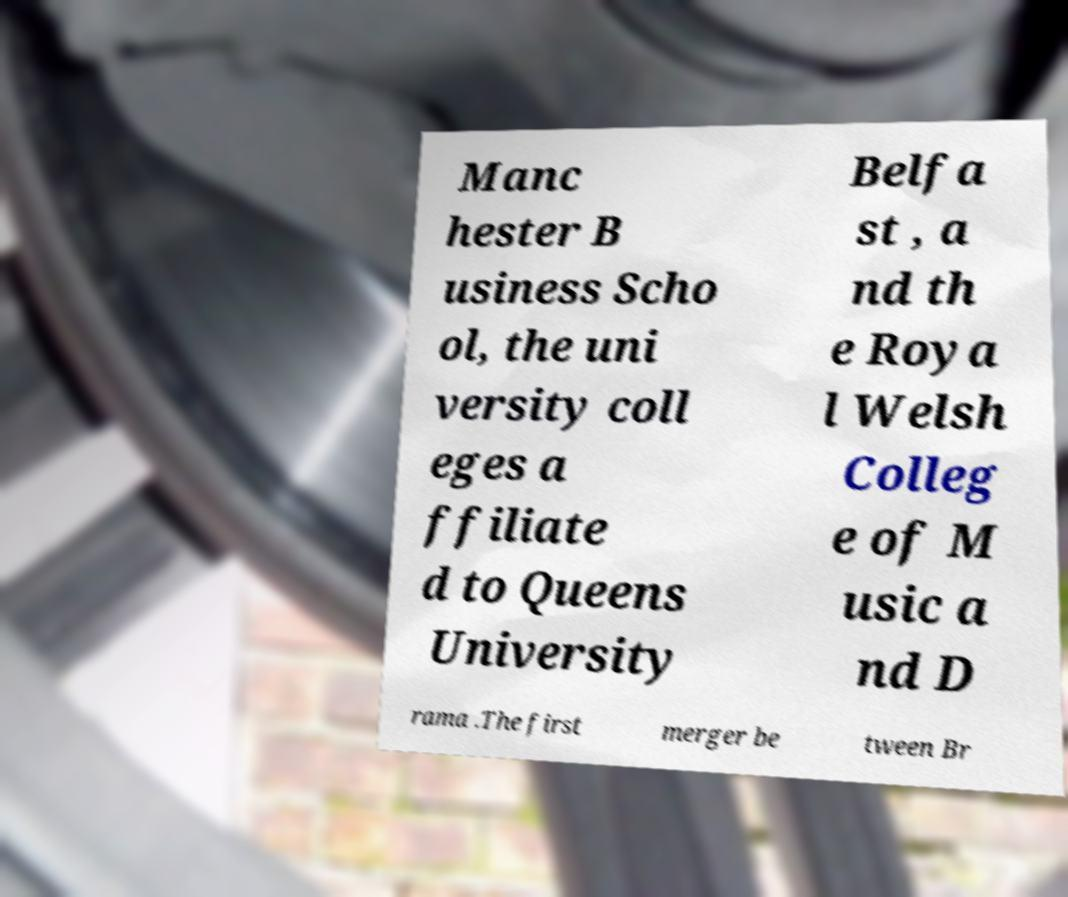Could you extract and type out the text from this image? Manc hester B usiness Scho ol, the uni versity coll eges a ffiliate d to Queens University Belfa st , a nd th e Roya l Welsh Colleg e of M usic a nd D rama .The first merger be tween Br 